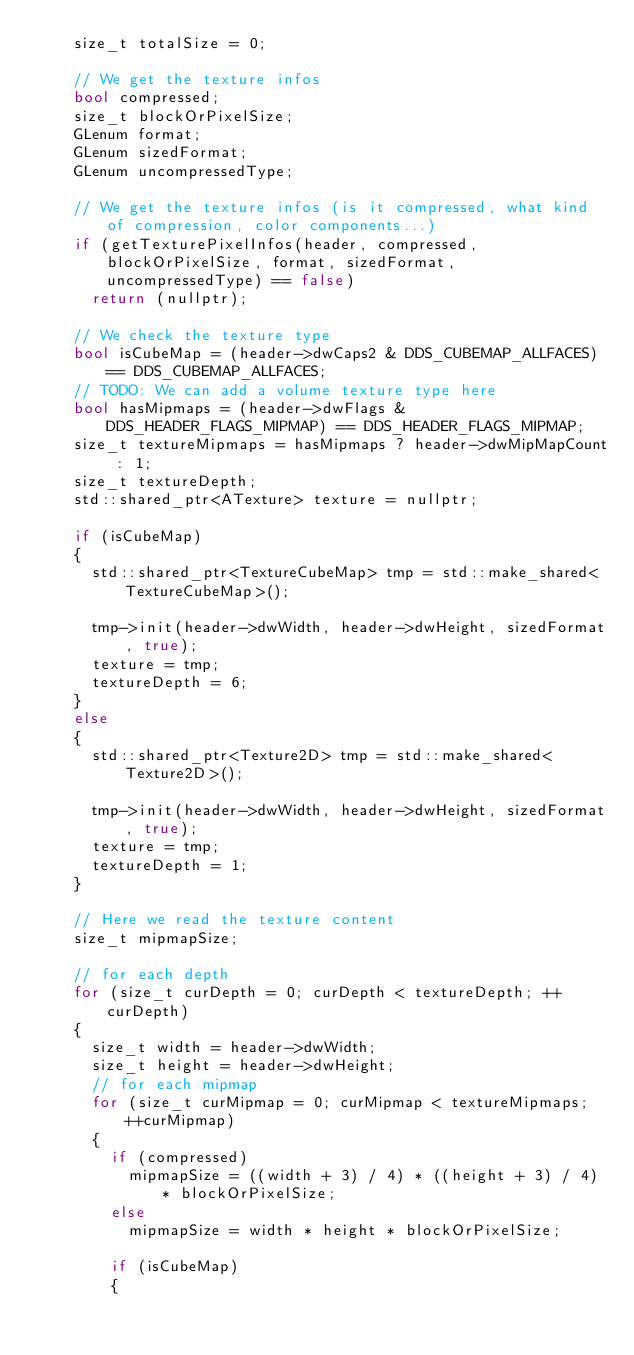Convert code to text. <code><loc_0><loc_0><loc_500><loc_500><_C++_>		size_t totalSize = 0;

		// We get the texture infos
		bool compressed;
		size_t blockOrPixelSize;
		GLenum format;
		GLenum sizedFormat;
		GLenum uncompressedType;

		// We get the texture infos (is it compressed, what kind of compression, color components...)
		if (getTexturePixelInfos(header, compressed, blockOrPixelSize, format, sizedFormat, uncompressedType) == false)
			return (nullptr);

		// We check the texture type
		bool isCubeMap = (header->dwCaps2 & DDS_CUBEMAP_ALLFACES) == DDS_CUBEMAP_ALLFACES;
		// TODO: We can add a volume texture type here
		bool hasMipmaps = (header->dwFlags & DDS_HEADER_FLAGS_MIPMAP) == DDS_HEADER_FLAGS_MIPMAP;
		size_t textureMipmaps = hasMipmaps ? header->dwMipMapCount : 1;
		size_t textureDepth;
		std::shared_ptr<ATexture> texture = nullptr;
		
		if (isCubeMap)
		{
			std::shared_ptr<TextureCubeMap> tmp = std::make_shared<TextureCubeMap>();

			tmp->init(header->dwWidth, header->dwHeight, sizedFormat, true);
			texture = tmp;
			textureDepth = 6;
		}
		else
		{
			std::shared_ptr<Texture2D> tmp = std::make_shared<Texture2D>();

			tmp->init(header->dwWidth, header->dwHeight, sizedFormat, true);
			texture = tmp;
			textureDepth = 1;
		}

		// Here we read the texture content
		size_t mipmapSize;

		// for each depth
		for (size_t curDepth = 0; curDepth < textureDepth; ++curDepth)
		{
			size_t width = header->dwWidth;
			size_t height = header->dwHeight;
			// for each mipmap
			for (size_t curMipmap = 0; curMipmap < textureMipmaps; ++curMipmap)
			{
				if (compressed)
					mipmapSize = ((width + 3) / 4) * ((height + 3) / 4) * blockOrPixelSize;
				else
					mipmapSize = width * height * blockOrPixelSize;

				if (isCubeMap)
				{</code> 